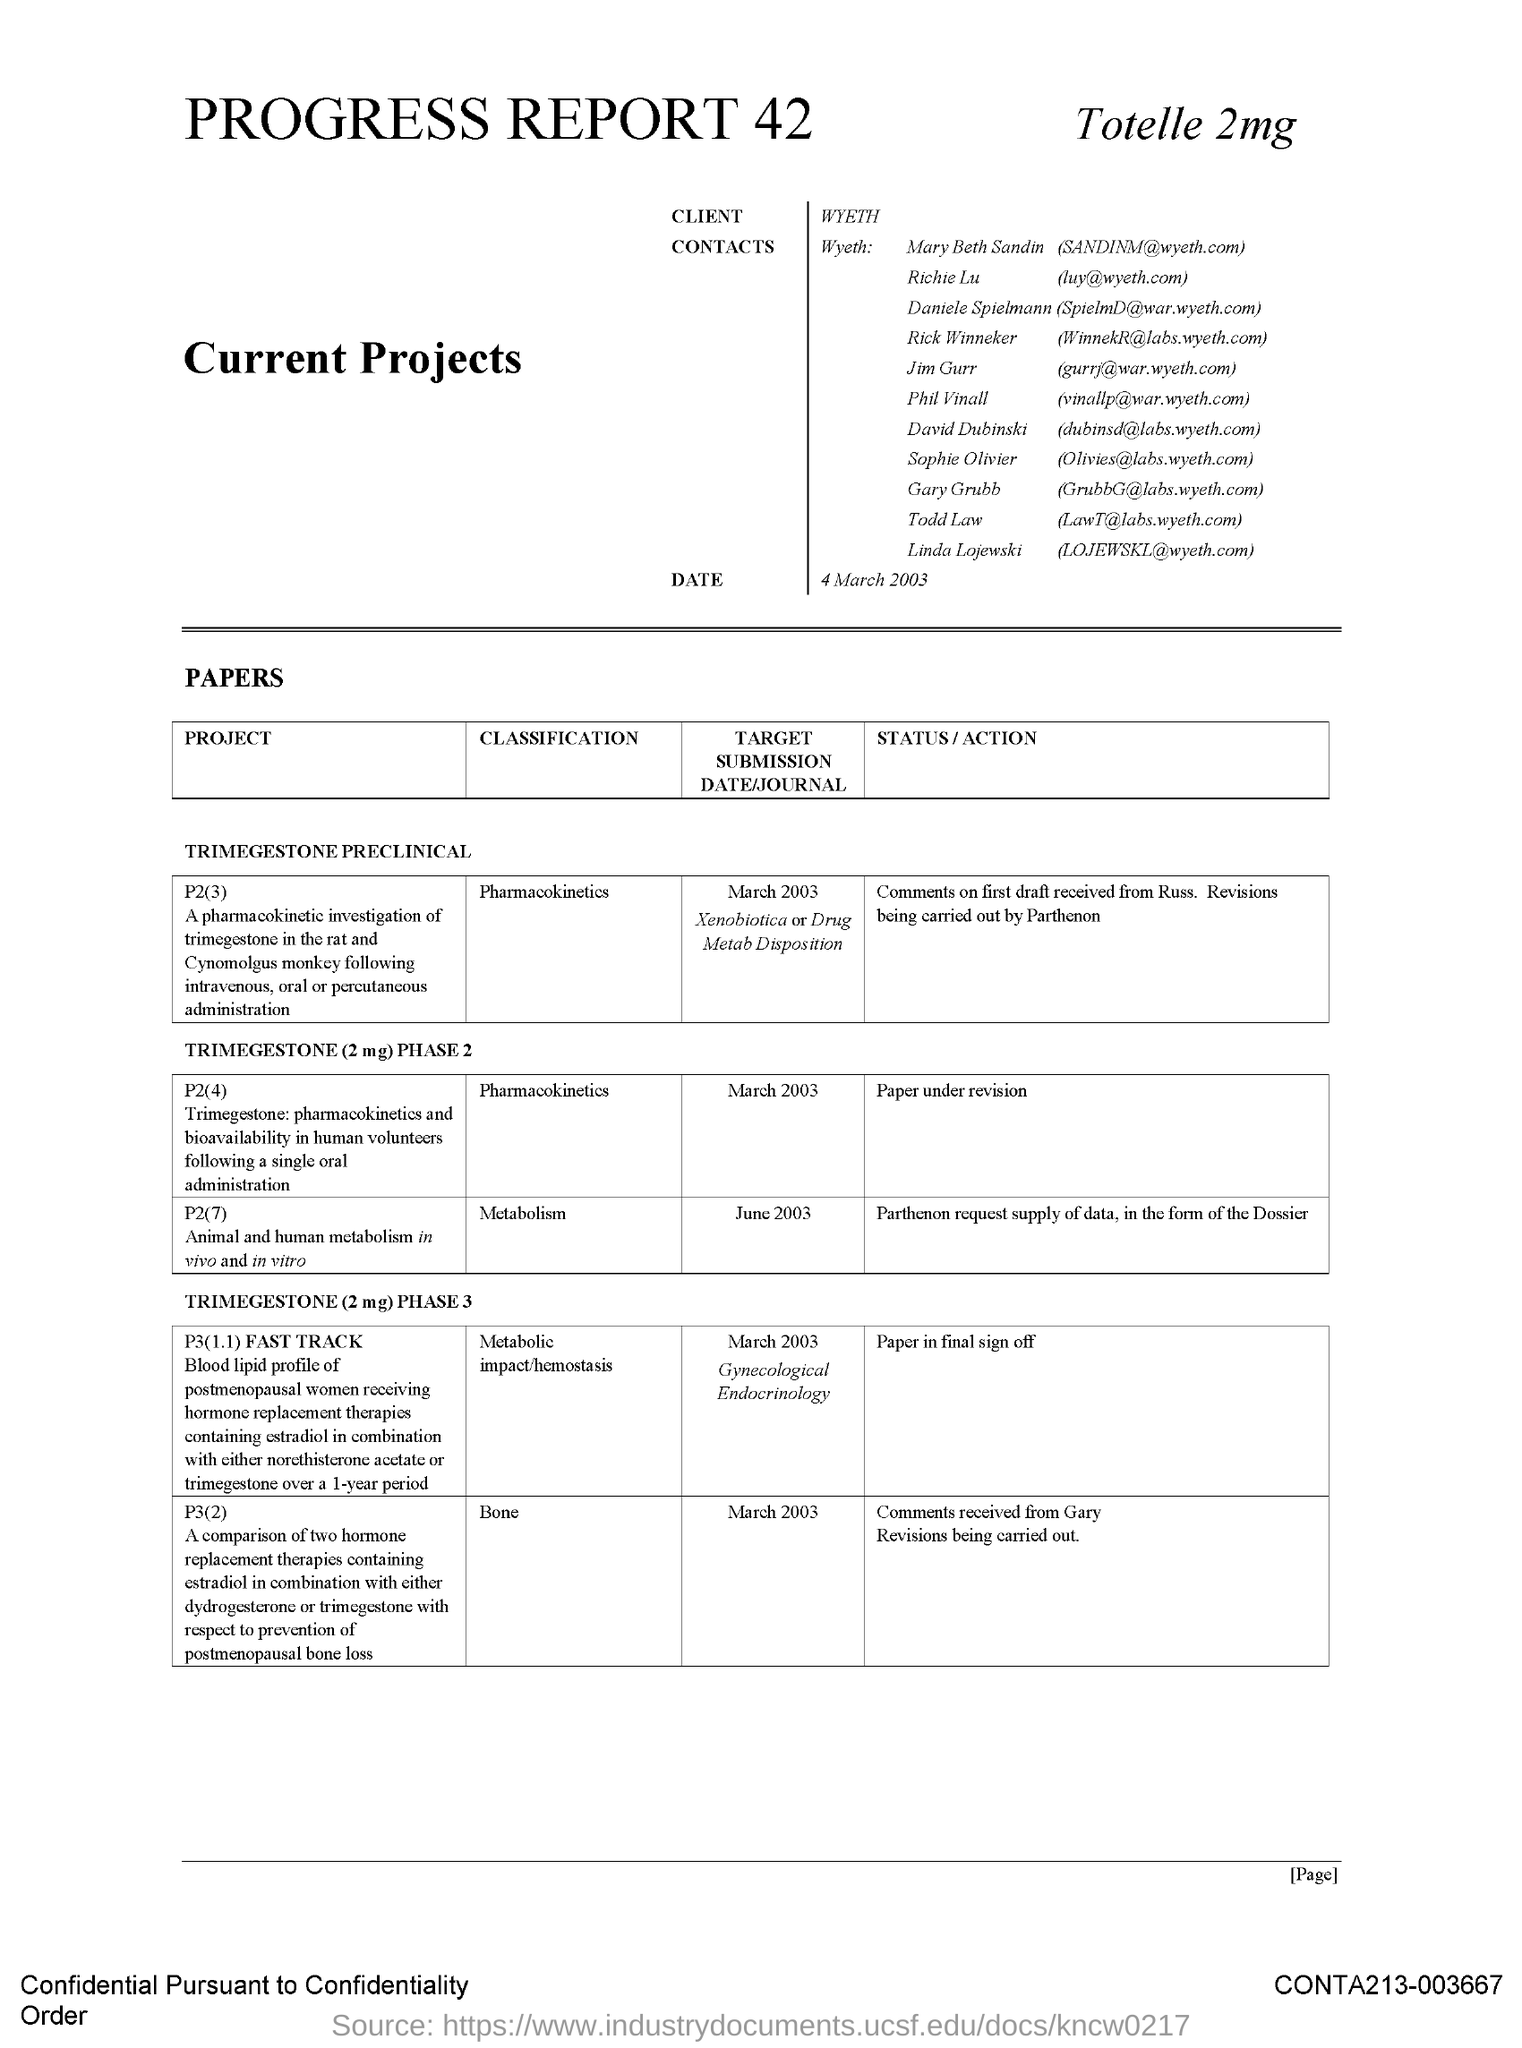Identify some key points in this picture. The classification in P3(2) is "Bone". 